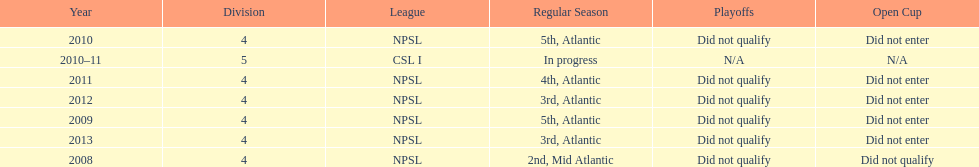Other than npsl, what league has ny mens soccer team played in? CSL I. 